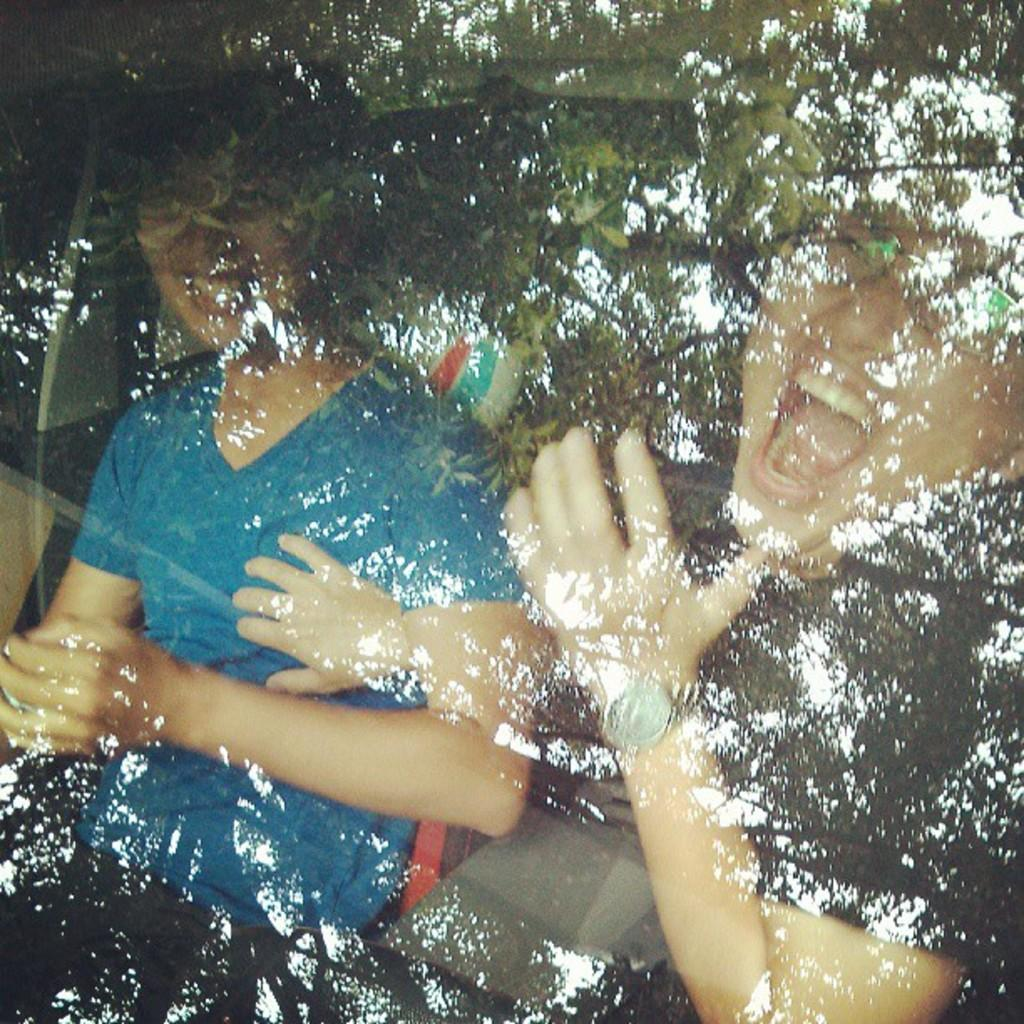How many people are present in the image? There are two people sitting in the image. What is the facial expression of the people in the image? Both people are smiling. Can you describe the clothing of one of the people? One person is wearing a blue t-shirt. What type of natural element can be seen in the image? There is a tree visible in the image. Where is the bed located in the image? There is no bed present in the image. What type of country is depicted in the image? There is no country depicted in the image; it features two people and a tree. 